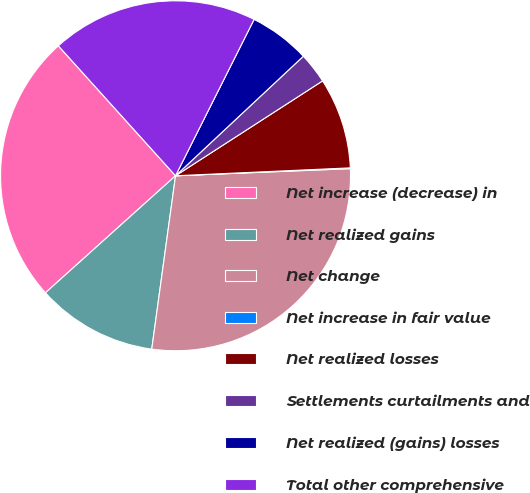Convert chart to OTSL. <chart><loc_0><loc_0><loc_500><loc_500><pie_chart><fcel>Net increase (decrease) in<fcel>Net realized gains<fcel>Net change<fcel>Net increase in fair value<fcel>Net realized losses<fcel>Settlements curtailments and<fcel>Net realized (gains) losses<fcel>Total other comprehensive<nl><fcel>24.98%<fcel>11.17%<fcel>27.82%<fcel>0.07%<fcel>8.4%<fcel>2.85%<fcel>5.62%<fcel>19.09%<nl></chart> 